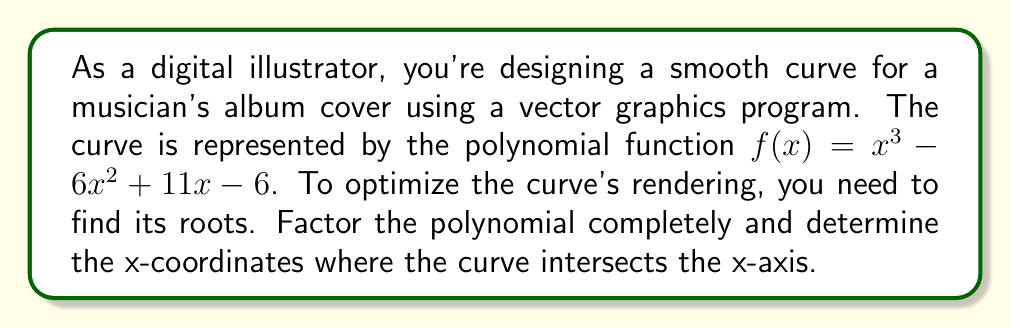Can you answer this question? To factor the polynomial $f(x) = x^3 - 6x^2 + 11x - 6$, we'll follow these steps:

1) First, let's check if there's a common factor. There isn't, so we proceed.

2) Next, we'll try to guess one root. Let's try some factors of the constant term (-6): ±1, ±2, ±3, ±6.
   Using the rational root theorem, we find that x = 1 is a root.

3) Divide the polynomial by (x - 1):

   $$(x^3 - 6x^2 + 11x - 6) ÷ (x - 1) = x^2 - 5x + 6$$

4) Now we have: $f(x) = (x - 1)(x^2 - 5x + 6)$

5) The quadratic factor $x^2 - 5x + 6$ can be factored further:
   
   $x^2 - 5x + 6 = (x - 2)(x - 3)$

6) Therefore, the complete factorization is:

   $f(x) = (x - 1)(x - 2)(x - 3)$

The roots of the polynomial are the x-coordinates where the curve intersects the x-axis. These are the values that make each factor equal to zero:

$x - 1 = 0$, so $x = 1$
$x - 2 = 0$, so $x = 2$
$x - 3 = 0$, so $x = 3$

These x-coordinates (1, 2, and 3) represent the points where the curve crosses the x-axis in your vector graphics program.
Answer: The polynomial factors as: $f(x) = (x - 1)(x - 2)(x - 3)$
The x-coordinates where the curve intersects the x-axis are: 1, 2, and 3. 